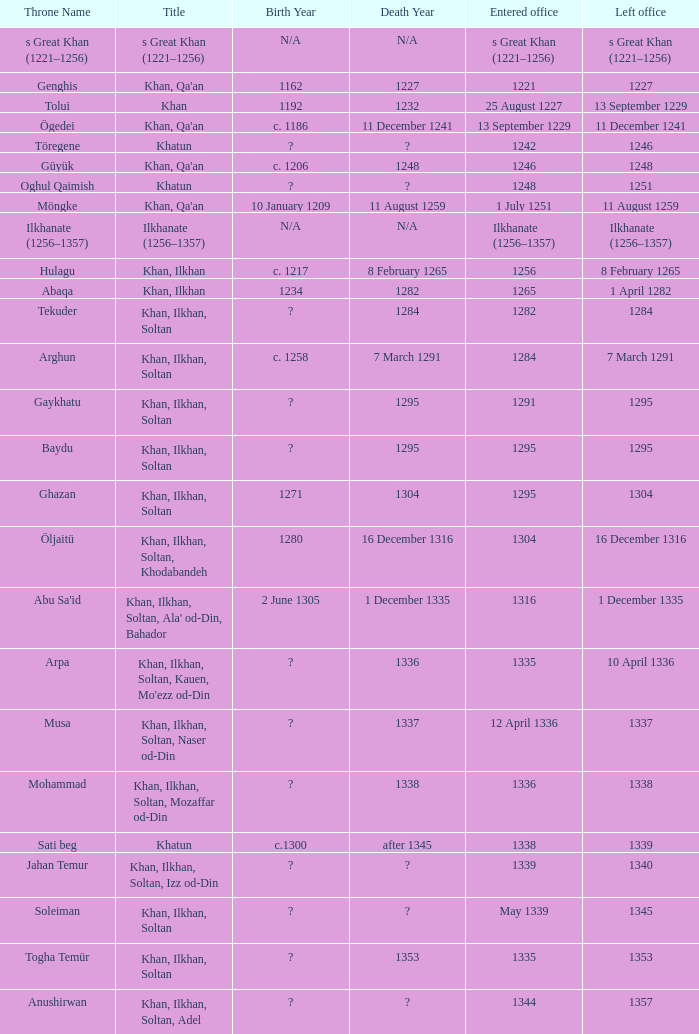What is the born-died that has office of 13 September 1229 as the entered? C. 1186 – 11 december 1241. 